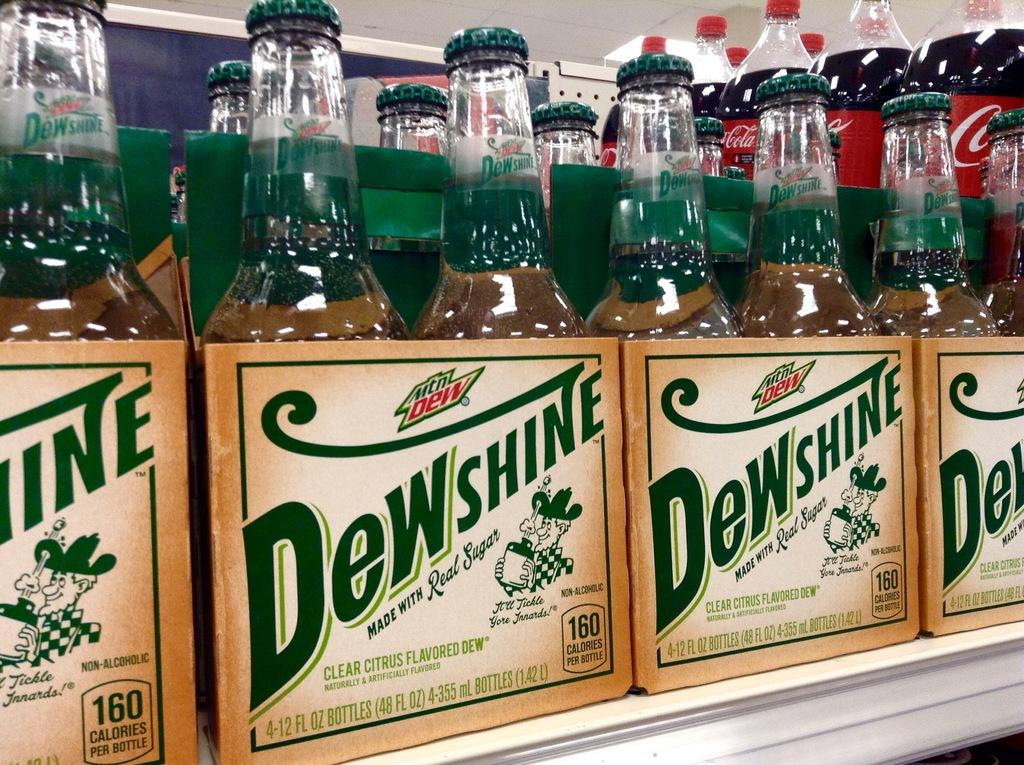<image>
Render a clear and concise summary of the photo. Six packs of Dewshine sit on a store shelf. 